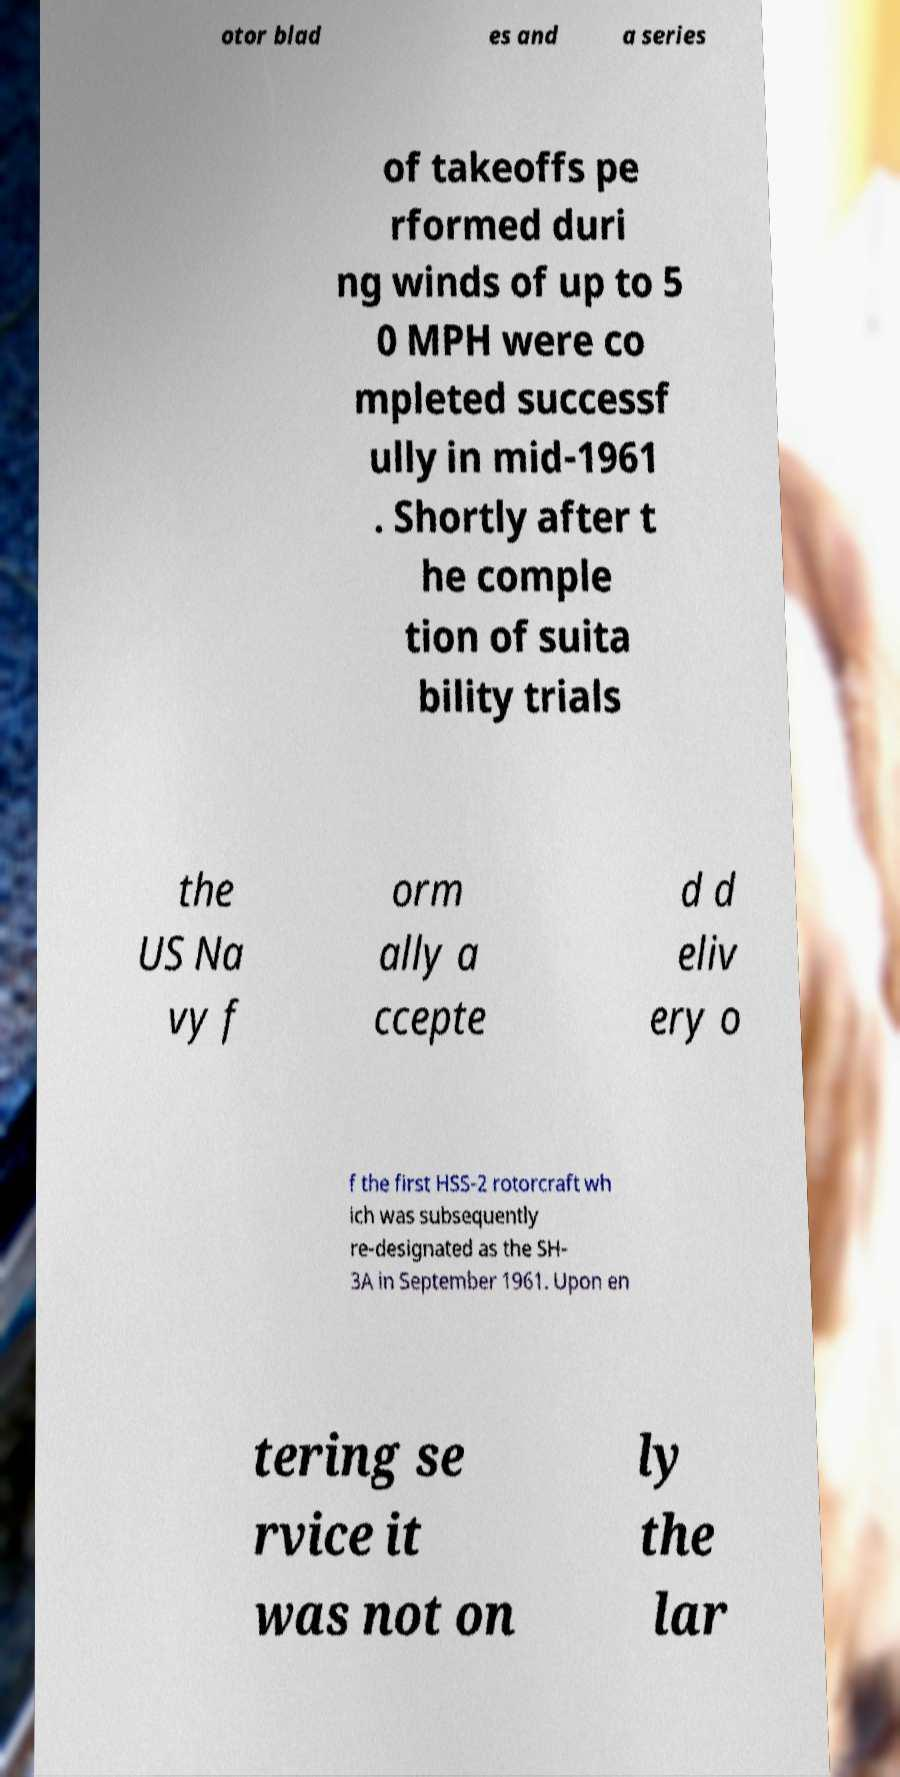Please identify and transcribe the text found in this image. otor blad es and a series of takeoffs pe rformed duri ng winds of up to 5 0 MPH were co mpleted successf ully in mid-1961 . Shortly after t he comple tion of suita bility trials the US Na vy f orm ally a ccepte d d eliv ery o f the first HSS-2 rotorcraft wh ich was subsequently re-designated as the SH- 3A in September 1961. Upon en tering se rvice it was not on ly the lar 